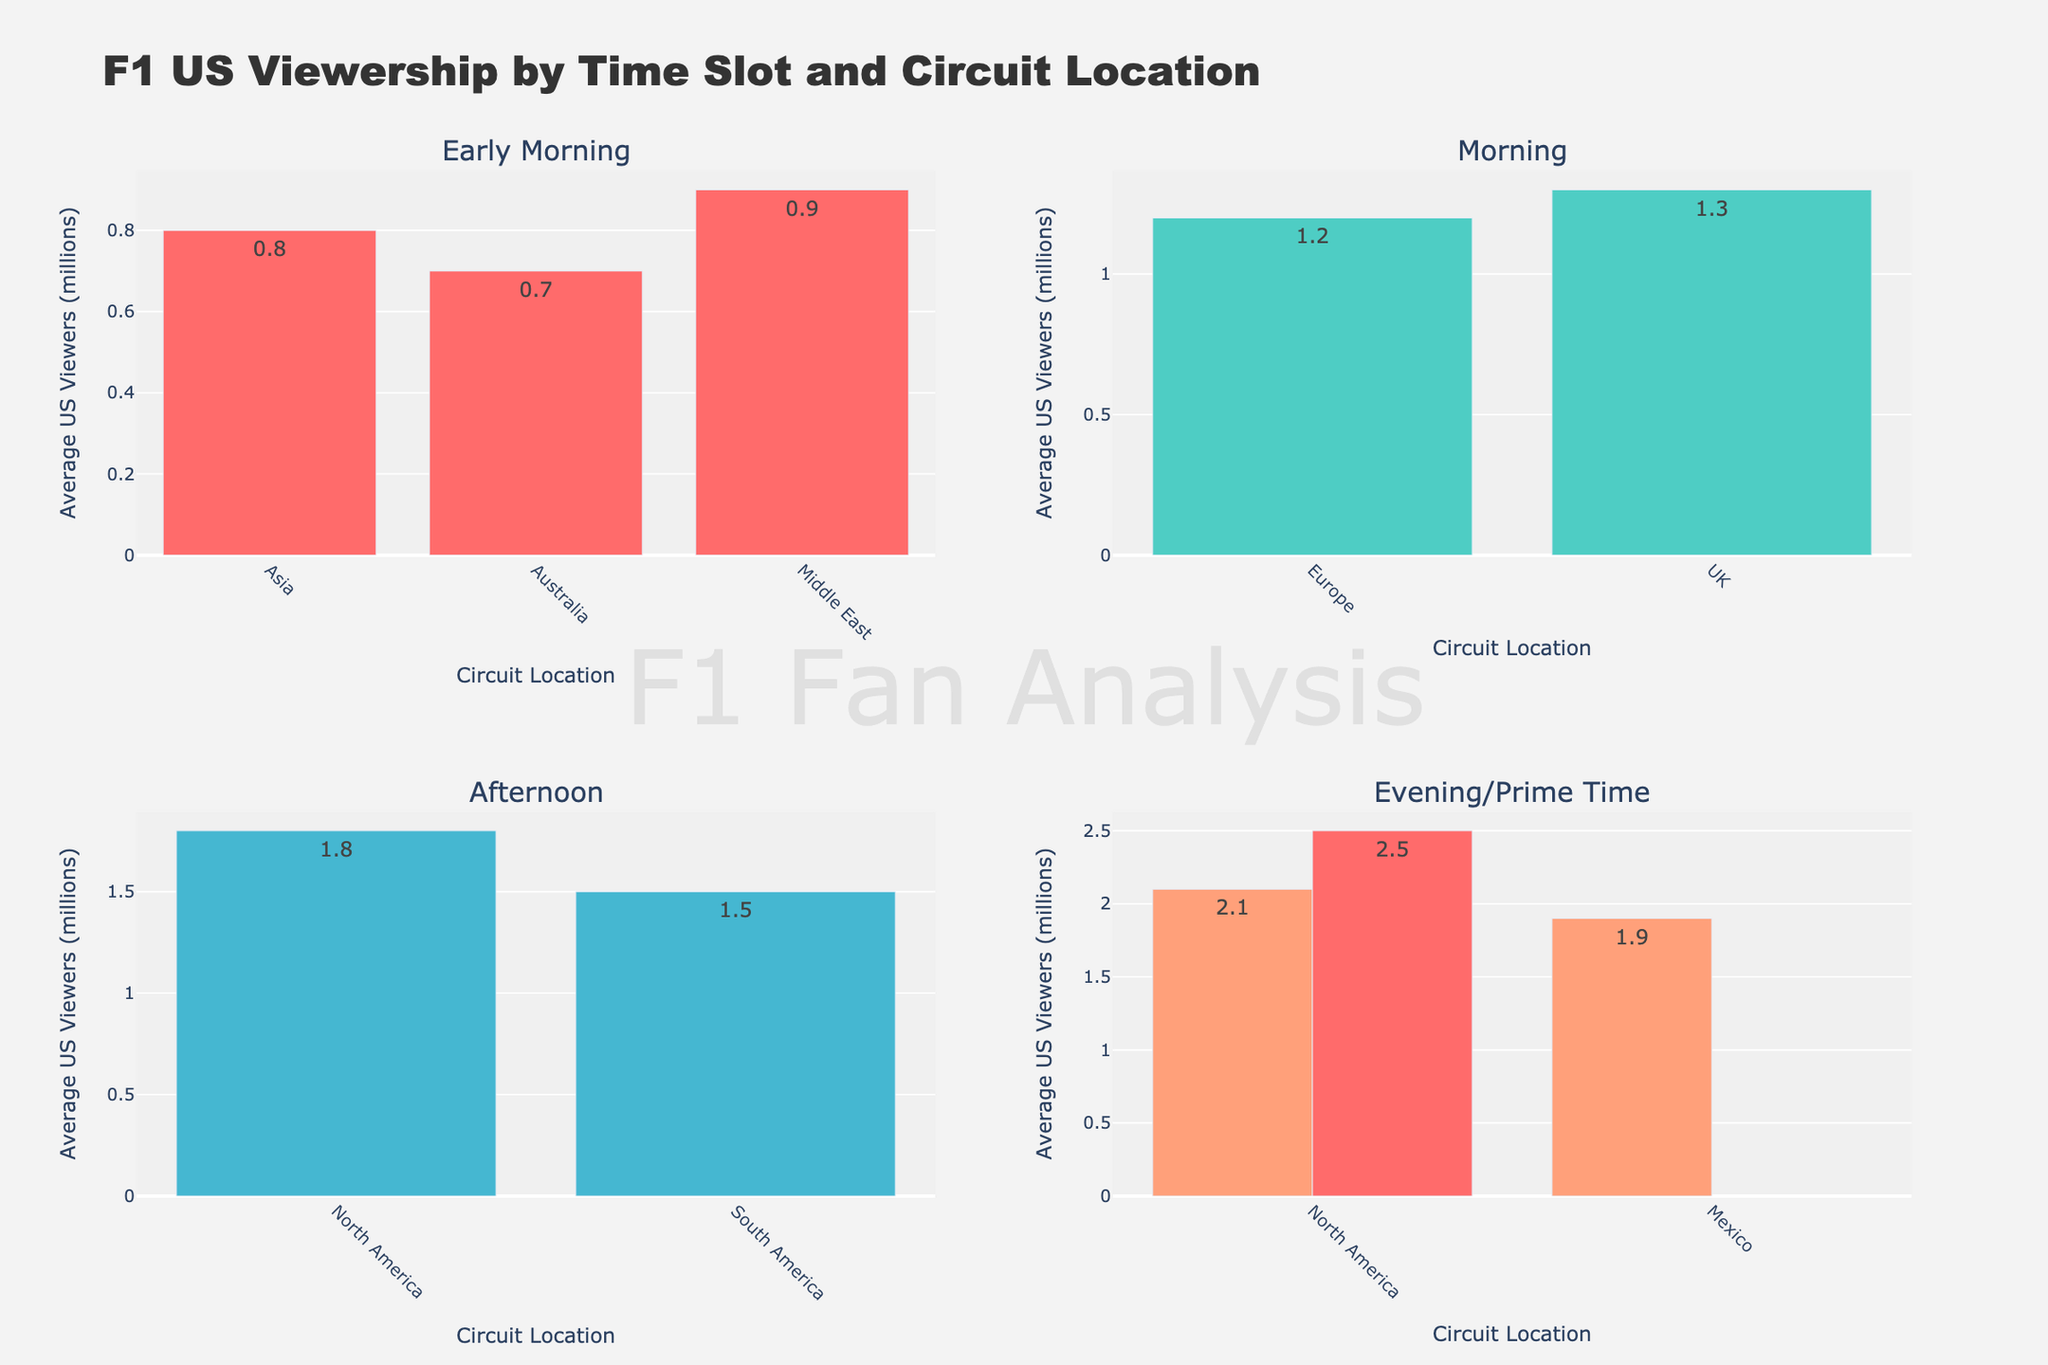what's the title of the figure? The title is displayed prominently at the top of the figure. Reading it directly gives us "F1 US Viewership by Time Slot and Circuit Location".
Answer: F1 US Viewership by Time Slot and Circuit Location how many data points are shown for the "Morning" time slot? By looking at the subplot labeled "Morning", we can count the bars representing circuit locations within that subplot. There are two bars for Europe and UK respectively.
Answer: 2 which circuit location has the highest average viewers in the "Morning" time slot? Within the "Morning" subplot, we compare the heights of the bars. The bar for the UK is higher than for Europe.
Answer: UK what is the average viewership for North America during "Prime Time"? North America's viewership during "Prime Time" is shown in the "Evening/Prime Time" subplot. Reading the value from the corresponding bar gives us the answer.
Answer: 2.5 million what are the average viewership numbers for circuits in the "Afternoon" time slot? From the "Afternoon" subplot, we can see the viewership values for North America and South America. The bars show values of 1.8 million and 1.5 million respectively.
Answer: 1.8 million and 1.5 million which time slot has the highest average viewership for North America? We need to look at the viewership bars for North America across all time slots. Prime Time has a viewership of 2.5 million, which is the highest among other times including Afternoon and Evening.
Answer: Prime Time how does the viewership in "Early Morning" for the Middle East compare to that in Asia? Refer to the "Early Morning" subplot and compare the heights of the bars for the Middle East at 0.9 million and Asia at 0.8 million.
Answer: Middle East is higher what is the combined average viewership for Australia and Asia in the "Early Morning" time slot? Adding the viewership values for Australia and Asia from the "Early Morning" subplot (0.7 million and 0.8 million respectively) gives a total of 1.5 million.
Answer: 1.5 million considering all time slots, which circuit location appears most frequently? We examine all subplots and count how often each circuit location appears. North America appears the most frequently across the subplots.
Answer: North America how does the viewership for Asia in the "Early Morning" compare to the UK in the "Morning"? We look at the "Early Morning" subplot for Asia (0.8 million) and the "Morning" subplot for the UK (1.3 million) and see that the UK's viewership is higher.
Answer: UK is higher 